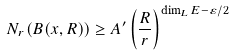<formula> <loc_0><loc_0><loc_500><loc_500>N _ { r } ( B ( x , R ) ) \geq A ^ { \prime } \left ( \frac { R } { r } \right ) ^ { \dim _ { L } E - \varepsilon / 2 }</formula> 